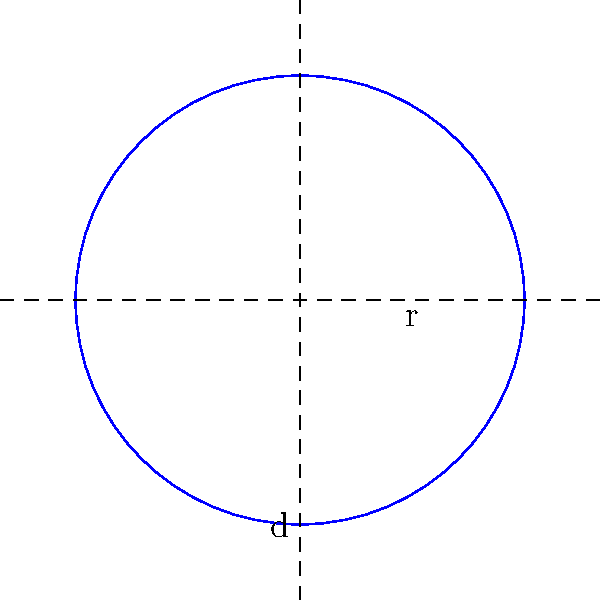As a safety-conscious farmer, you want to enclose a circular pasture with a diameter of 60 meters using sturdy fencing. How many meters of fencing material should you purchase to completely surround the pasture, ensuring no weak points in the enclosure? To determine the length of fencing needed, we need to calculate the circumference of the circular pasture. Let's approach this step-by-step:

1) We are given the diameter (d) of the pasture: 60 meters.

2) The circumference (C) of a circle is related to its diameter (d) by the formula:
   $C = \pi d$

3) Substituting the given diameter:
   $C = \pi \times 60$

4) $\pi$ is approximately 3.14159, so:
   $C \approx 3.14159 \times 60 = 188.49540$ meters

5) As a cautious farmer, it's wise to round up to ensure we have enough fencing material. Let's round to the nearest meter:
   $C \approx 189$ meters

Therefore, to ensure we have enough fencing material to completely enclose the pasture without any weak points, we should purchase 189 meters of fencing.
Answer: 189 meters 